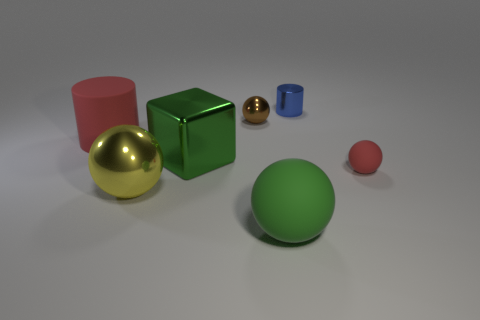Subtract all small red balls. How many balls are left? 3 Add 3 yellow cubes. How many objects exist? 10 Subtract all red cylinders. How many cylinders are left? 1 Add 3 large red cylinders. How many large red cylinders are left? 4 Add 3 large matte blocks. How many large matte blocks exist? 3 Subtract 0 cyan blocks. How many objects are left? 7 Subtract all balls. How many objects are left? 3 Subtract 2 cylinders. How many cylinders are left? 0 Subtract all cyan blocks. Subtract all brown balls. How many blocks are left? 1 Subtract all small purple rubber cubes. Subtract all matte spheres. How many objects are left? 5 